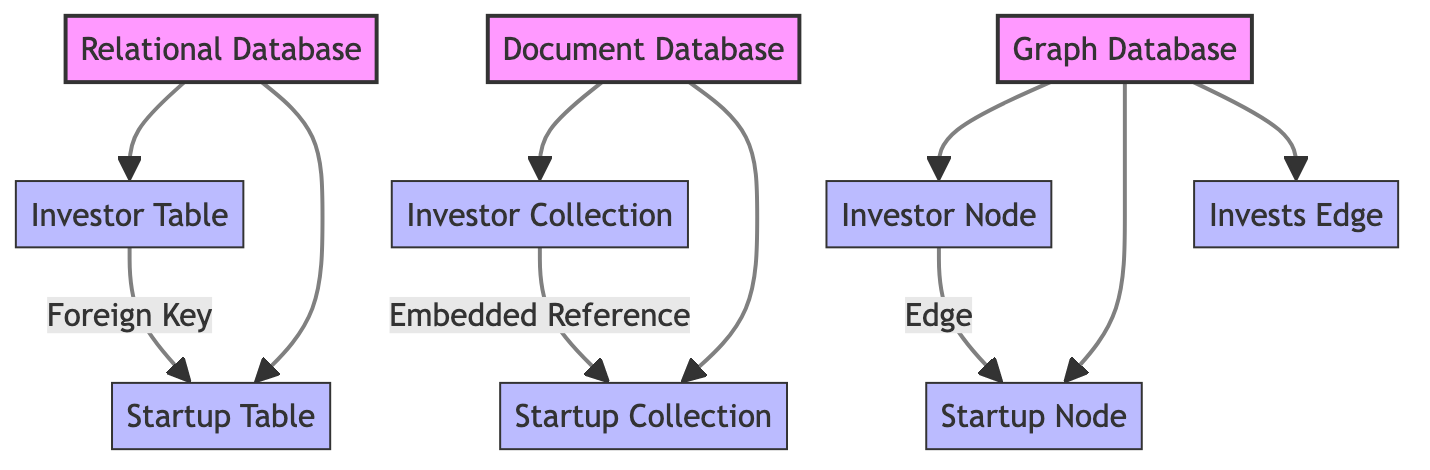What are the three types of database models depicted in the diagram? The diagram shows three database models: Relational Database, Document Database, and Graph Database. These are the primary nodes at the top of the diagram.
Answer: Relational Database, Document Database, Graph Database How many total tables and collections are represented in the diagram? The diagram features two tables (Investor Table and Startup Table) and two collections (Investor Collection and Startup Collection), totaling four components.
Answer: Four What is the relationship between the Investor Table and the Startup Table? The diagram indicates a Foreign Key relationship from the Investor Table to the Startup Table, showing that investors might be linked to specific startups through keys.
Answer: Foreign Key Which database model handles data with edges and nodes? The Graph Database is designed to manage data through relationships represented as edges and nodes, as shown in the respective connections in the diagram.
Answer: Graph Database How does the Document Database link investor and startup data? In the Document Database, the Investor Collection is linked to the Startup Collection through an Embedded Reference, which allows data to be nested within documents.
Answer: Embedded Reference What type of component does the Graph Database use to represent investors and startups? The Graph Database uses nodes to represent both investors and startups, illustrating a network-like structure for relationships.
Answer: Nodes How many edges are present in the Graph Database part of the diagram? There is one edge shown in the diagram, labeled as "Invests Edge," which connects the Investor Node to the Startup Node.
Answer: One Which database model utilizes embedded references? The Document Database utilizes embedded references to relate investor and startup data, as indicated by the diagram.
Answer: Document Database What is the visual distinction between the three database models in the diagram? Each database model has a unique color fill: Relational Database has light red, Document Database has light green, and Graph Database has light blue, making them easily distinguishable.
Answer: Different colors 